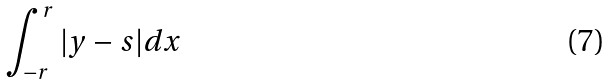Convert formula to latex. <formula><loc_0><loc_0><loc_500><loc_500>\int _ { - r } ^ { r } | y - s | d x</formula> 